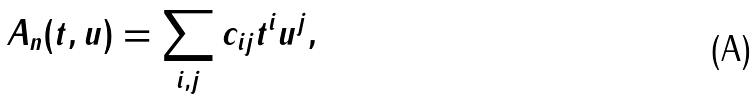Convert formula to latex. <formula><loc_0><loc_0><loc_500><loc_500>A _ { n } ( t , u ) = \sum _ { i , j } c _ { i j } t ^ { i } u ^ { j } ,</formula> 